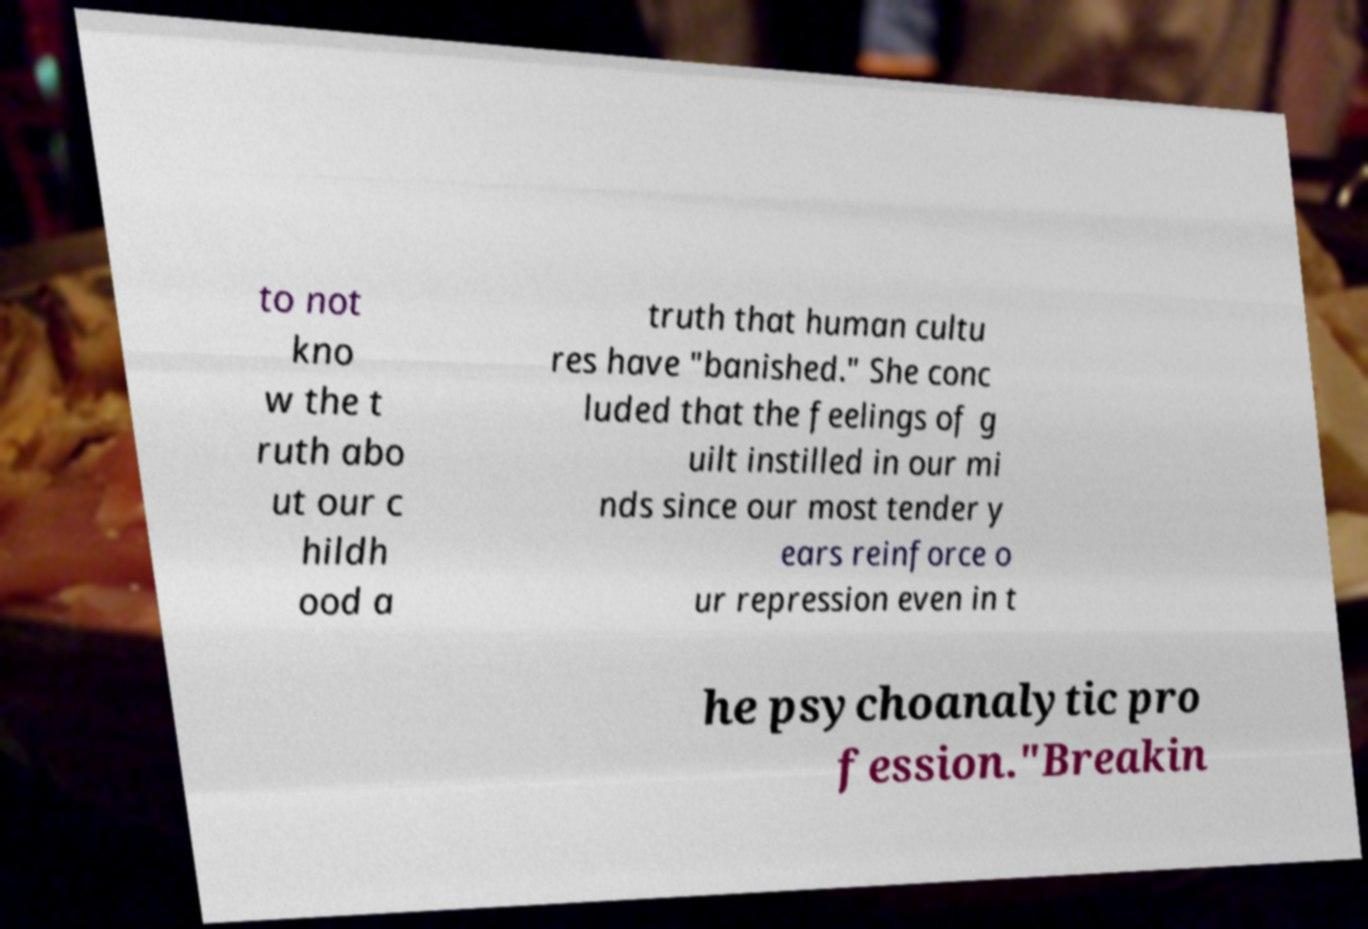There's text embedded in this image that I need extracted. Can you transcribe it verbatim? to not kno w the t ruth abo ut our c hildh ood a truth that human cultu res have "banished." She conc luded that the feelings of g uilt instilled in our mi nds since our most tender y ears reinforce o ur repression even in t he psychoanalytic pro fession."Breakin 